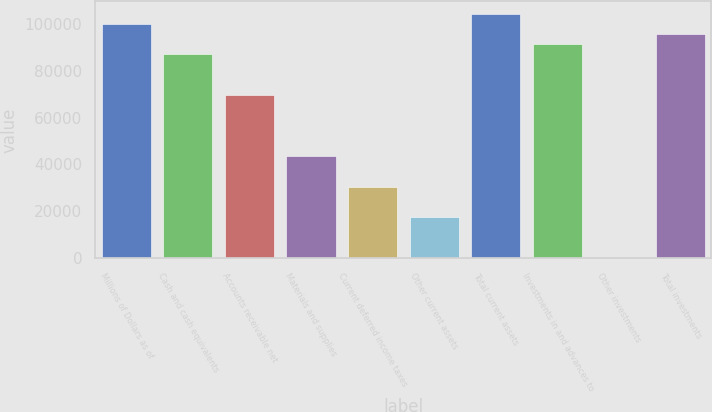<chart> <loc_0><loc_0><loc_500><loc_500><bar_chart><fcel>Millions of Dollars as of<fcel>Cash and cash equivalents<fcel>Accounts receivable net<fcel>Materials and supplies<fcel>Current deferred income taxes<fcel>Other current assets<fcel>Total current assets<fcel>Investments in and advances to<fcel>Other investments<fcel>Total investments<nl><fcel>99914.8<fcel>86884<fcel>69509.6<fcel>43448<fcel>30417.2<fcel>17386.4<fcel>104258<fcel>91227.6<fcel>12<fcel>95571.2<nl></chart> 